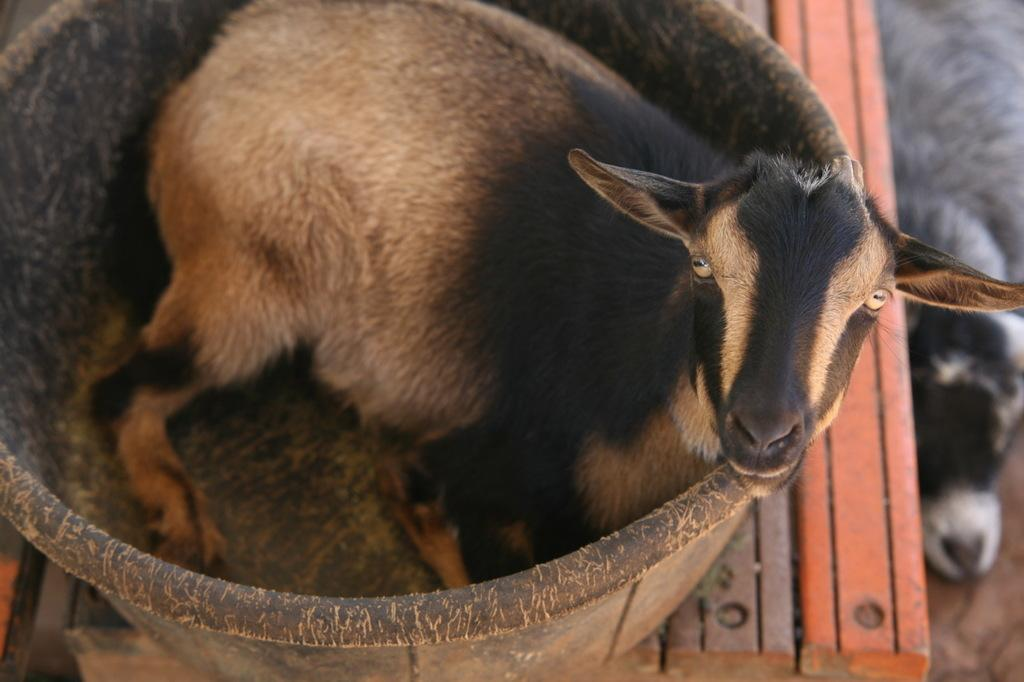What type of animal is in the image? There is a sheep in the image. Where is the sheep located? The sheep is in a tub. What is the tub resting on? The tub is on a table. Can you describe the animal at the bottom of the image? There is no animal at the bottom of the image. What type of wax can be seen melting in the image? There is no wax present in the image. How many mice are visible in the image? There are no mice visible in the image. 